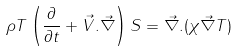Convert formula to latex. <formula><loc_0><loc_0><loc_500><loc_500>\rho T \left ( \frac { \partial } { \partial t } + \vec { V } . \vec { \nabla } \right ) S = \vec { \nabla } . ( \chi \vec { \nabla } T )</formula> 